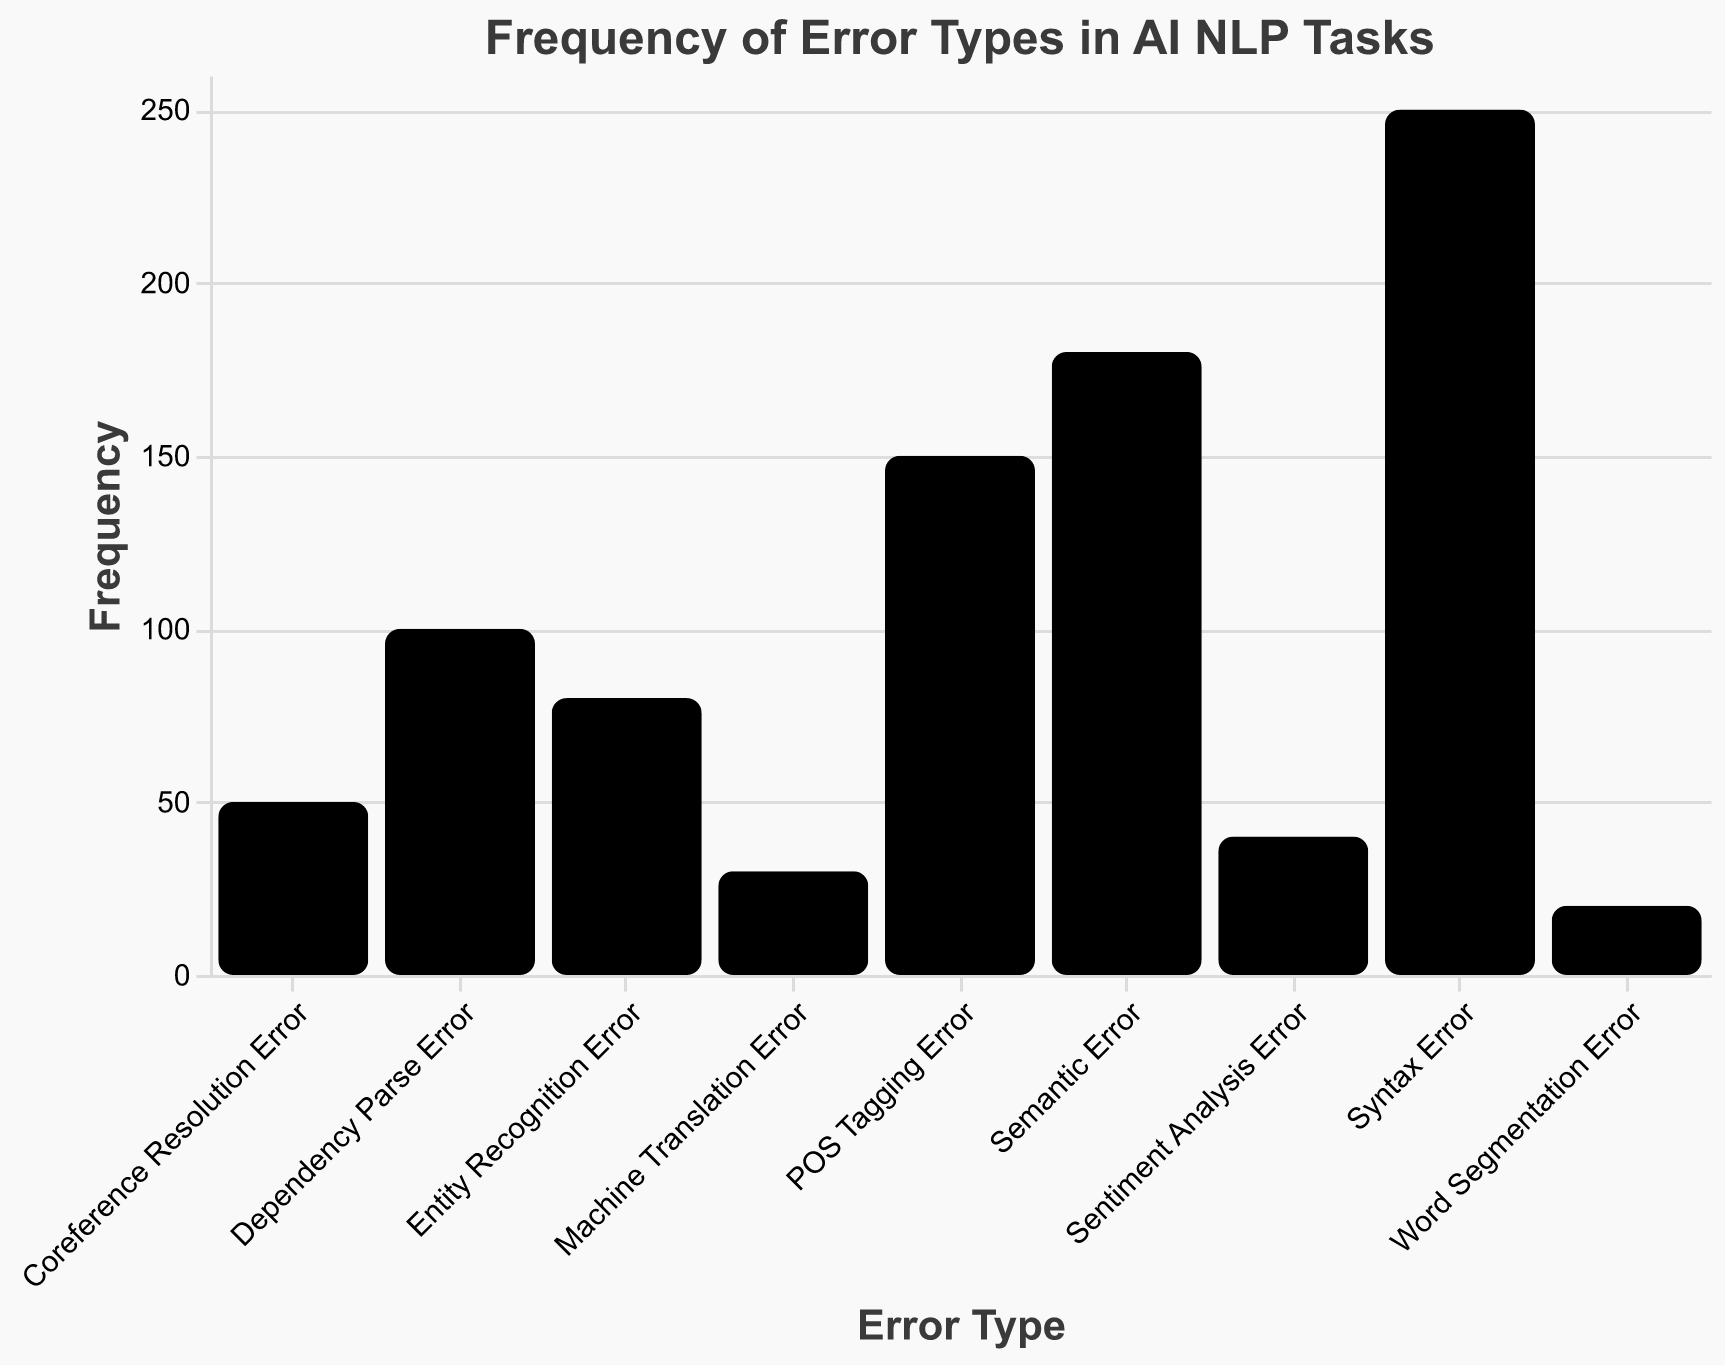Which error type has the highest frequency? Look at the height of the bars, the tallest one represents "Syntax Error," which has the highest count.
Answer: Syntax Error How many error types have a count greater than 100? Identify and count the bars which have heights corresponding to counts above 100. These are "Syntax Error," "Semantic Error," and "POS Tagging Error."
Answer: 3 What is the total frequency of "Entity Recognition Error" and "Coreference Resolution Error"? Identify the counts for both error types (80 for Entity Recognition Error and 50 for Coreference Resolution Error) and add them together: 80 + 50 = 130.
Answer: 130 Which error type has the smallest frequency? Look at the heights of the bars, the shortest one represents "Word Segmentation Error," which has the lowest count.
Answer: Word Segmentation Error What is the difference in frequency between "Semantic Error" and "Machine Translation Error"? Identify the counts for both error types (180 for Semantic Error and 30 for Machine Translation Error) and compute the difference: 180 - 30 = 150.
Answer: 150 How does the frequency of "POS Tagging Error" compare to "Dependency Parse Error"? Compare the heights of the two bars. "POS Tagging Error" has a count of 150, while "Dependency Parse Error" has a count of 100.
Answer: Greater Which two error types combined have a frequency closest to 200? Sum the counts of different pairs of error types and find the pair that is closest to 200. "Dependency Parse Error" (100) and "Entity Recognition Error" (80) sum to 180, which is closest to 200.
Answer: Dependency Parse Error and Entity Recognition Error What is the average frequency of all the error types? Sum the counts of all error types and divide by the number of error types: (250 + 180 + 150 + 100 + 80 + 50 + 40 + 30 + 20) / 9 = 100.
Answer: 100 How many error types have a count that falls between 50 and 150? Identify the bars whose heights correspond to counts within this range: "POS Tagging Error" (150), "Dependency Parse Error" (100), and "Entity Recognition Error" (80); there are 3 such error types.
Answer: 3 